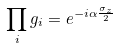Convert formula to latex. <formula><loc_0><loc_0><loc_500><loc_500>\prod _ { i } g _ { i } = e ^ { - i \alpha \frac { \sigma _ { z } } { 2 } }</formula> 